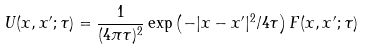<formula> <loc_0><loc_0><loc_500><loc_500>U ( x , x ^ { \prime } ; \tau ) = \frac { 1 } { ( 4 \pi \tau ) ^ { 2 } } \exp \left ( { - | x - x ^ { \prime } | ^ { 2 } / 4 \tau } \right ) F ( x , x ^ { \prime } ; \tau )</formula> 